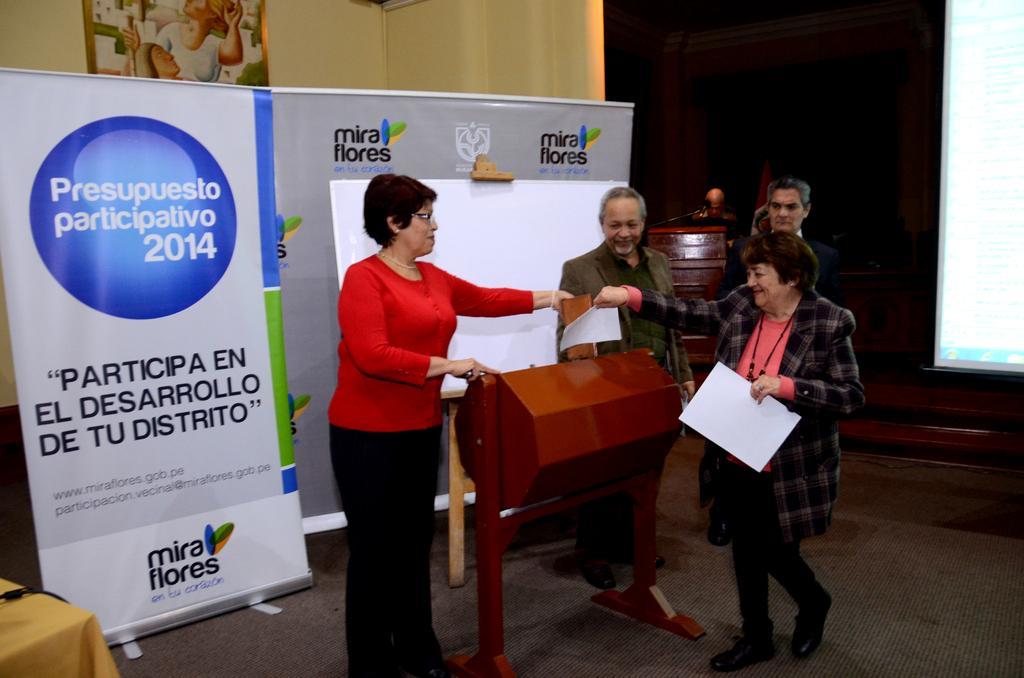Please provide a concise description of this image. There are three persons standing and this woman walking and holding papers,behind these persons we can see banners,board and frame on the wall. Right side of the image we can see screen. On the background we can see person,in front of this person we can see microphone with podium. 